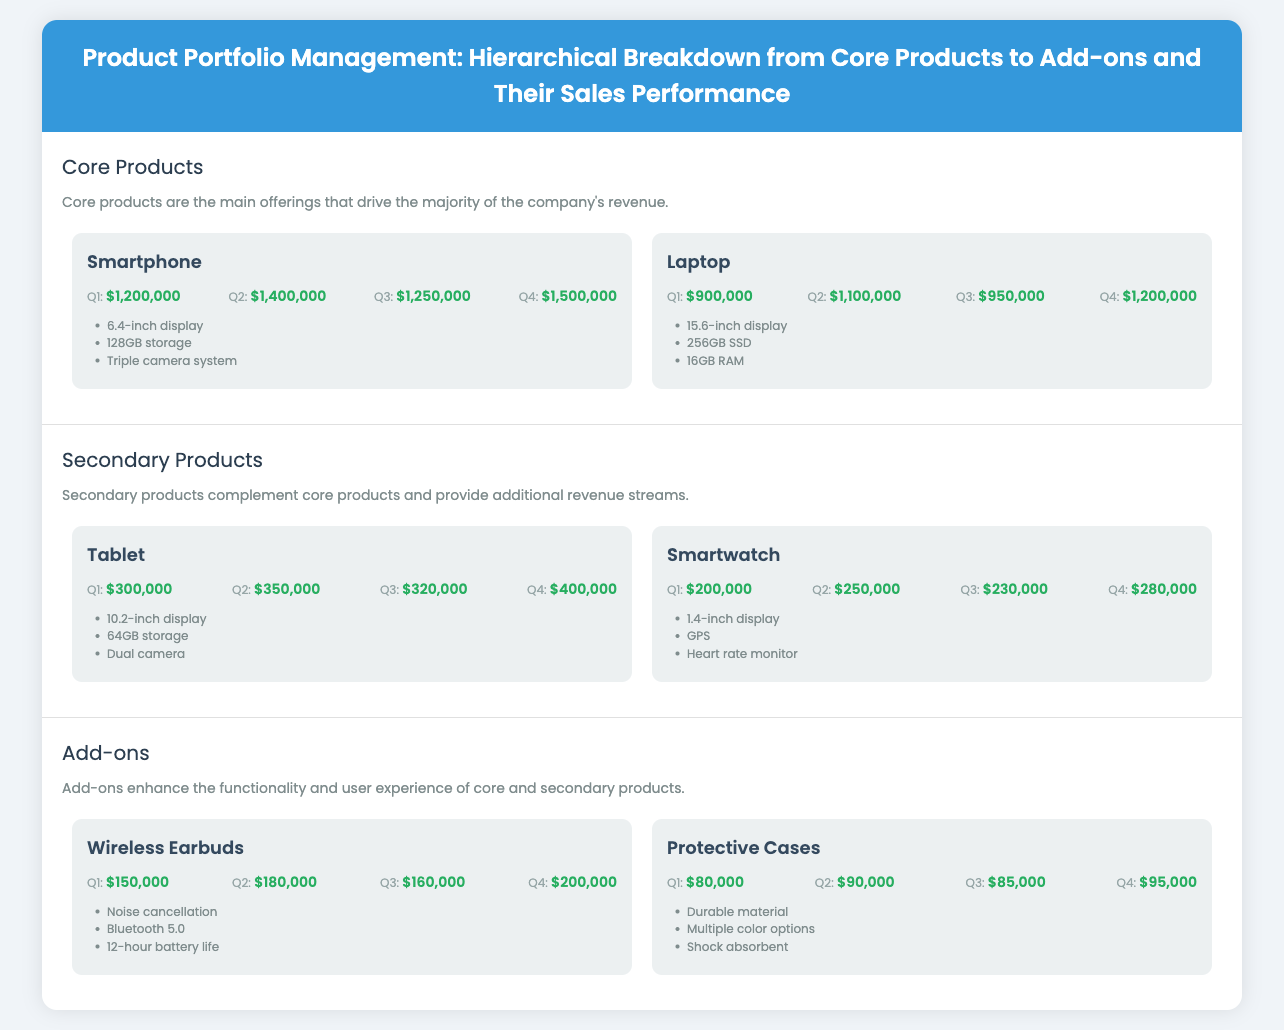What is the total revenue from Smartphone in Q4? The revenue for Smartphone in Q4 is indicated in the document as $1,500,000.
Answer: $1,500,000 Which product has the highest revenue in Q2? By comparing the Q2 sales, the highest revenue comes from Smartphone at $1,400,000.
Answer: Smartphone What feature does the Wireless Earbuds have? The features of Wireless Earbuds include noise cancellation as listed in the document.
Answer: Noise cancellation How much revenue did the Tablet generate in Q3? The revenue generated by the Tablet in Q3 is recorded as $320,000.
Answer: $320,000 Which core product has a larger display? Comparing the display sizes, the Laptop has a 15.6-inch display, which is larger than the Smartphone's 6.4-inch display.
Answer: Laptop What is the total revenue from Protective Cases in Q1? The revenue from Protective Cases in Q1 is mentioned as $80,000.
Answer: $80,000 Which product belongs to the Add-ons category? From the list of products, Wireless Earbuds are categorized as Add-ons.
Answer: Wireless Earbuds What feature do Smartwatches have? One of the features of Smartwatches is a heart rate monitor as listed in the document.
Answer: Heart rate monitor 